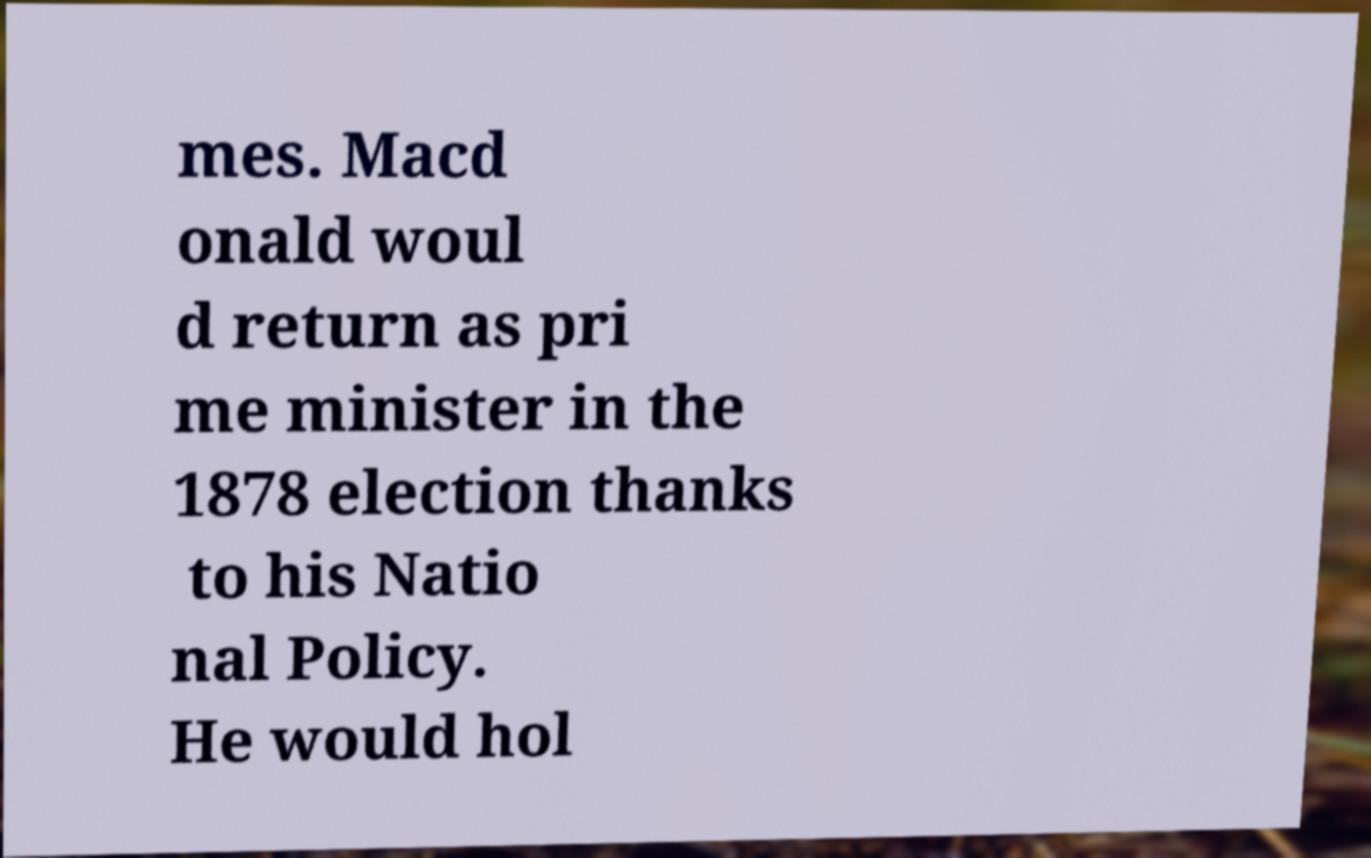I need the written content from this picture converted into text. Can you do that? mes. Macd onald woul d return as pri me minister in the 1878 election thanks to his Natio nal Policy. He would hol 